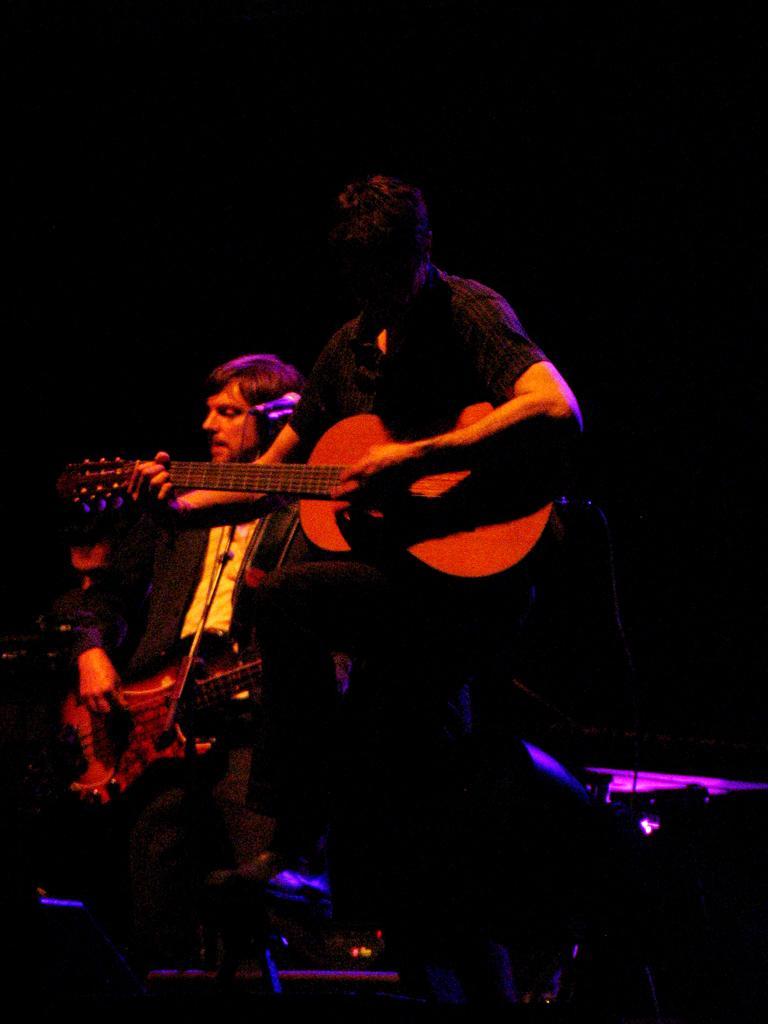Can you describe this image briefly? There are two people standing and playing guitar. This is the mic attached to the mike stand. The background looks dark. Here I can see another person standing. 